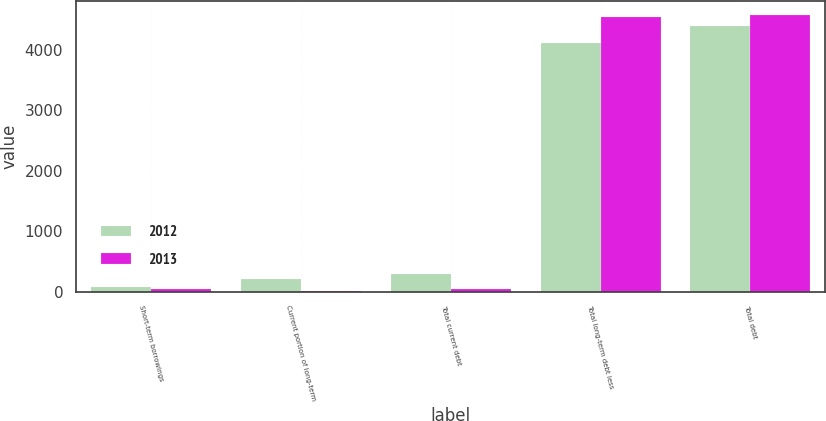Convert chart to OTSL. <chart><loc_0><loc_0><loc_500><loc_500><stacked_bar_chart><ecel><fcel>Short-term borrowings<fcel>Current portion of long-term<fcel>Total current debt<fcel>Total long-term debt less<fcel>Total debt<nl><fcel>2012<fcel>81.6<fcel>201.5<fcel>283.1<fcel>4116.4<fcel>4399.5<nl><fcel>2013<fcel>39.2<fcel>1.8<fcel>41<fcel>4540.8<fcel>4581.8<nl></chart> 